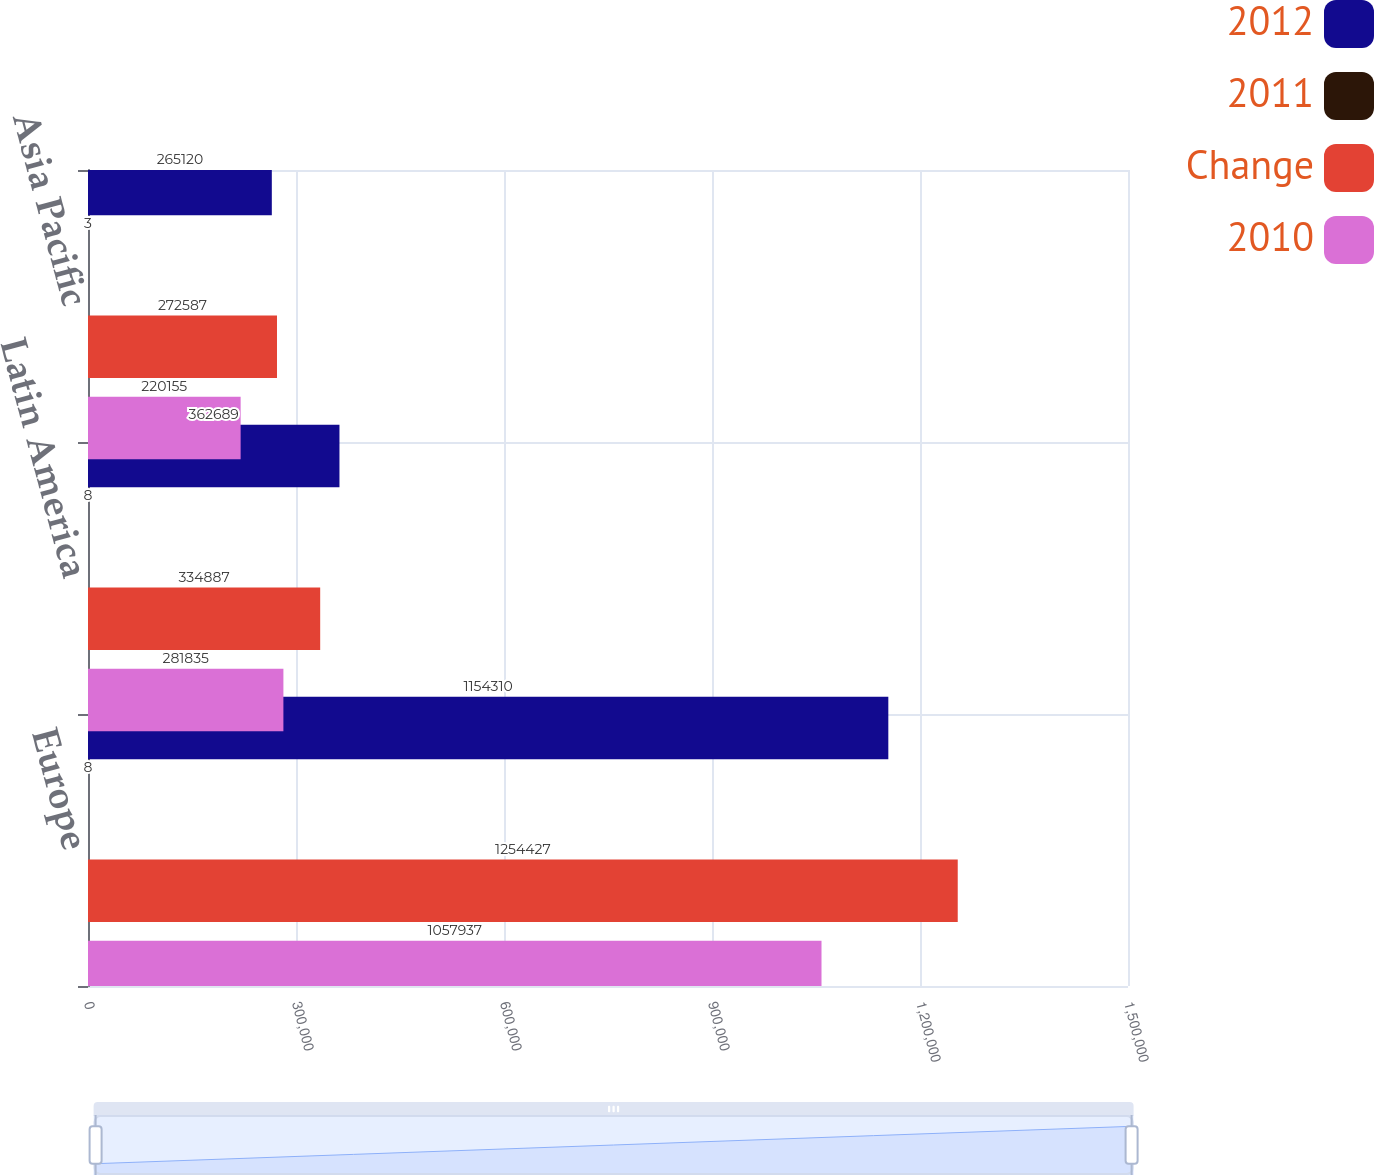<chart> <loc_0><loc_0><loc_500><loc_500><stacked_bar_chart><ecel><fcel>Europe<fcel>Latin America<fcel>Asia Pacific<nl><fcel>2012<fcel>1.15431e+06<fcel>362689<fcel>265120<nl><fcel>2011<fcel>8<fcel>8<fcel>3<nl><fcel>Change<fcel>1.25443e+06<fcel>334887<fcel>272587<nl><fcel>2010<fcel>1.05794e+06<fcel>281835<fcel>220155<nl></chart> 